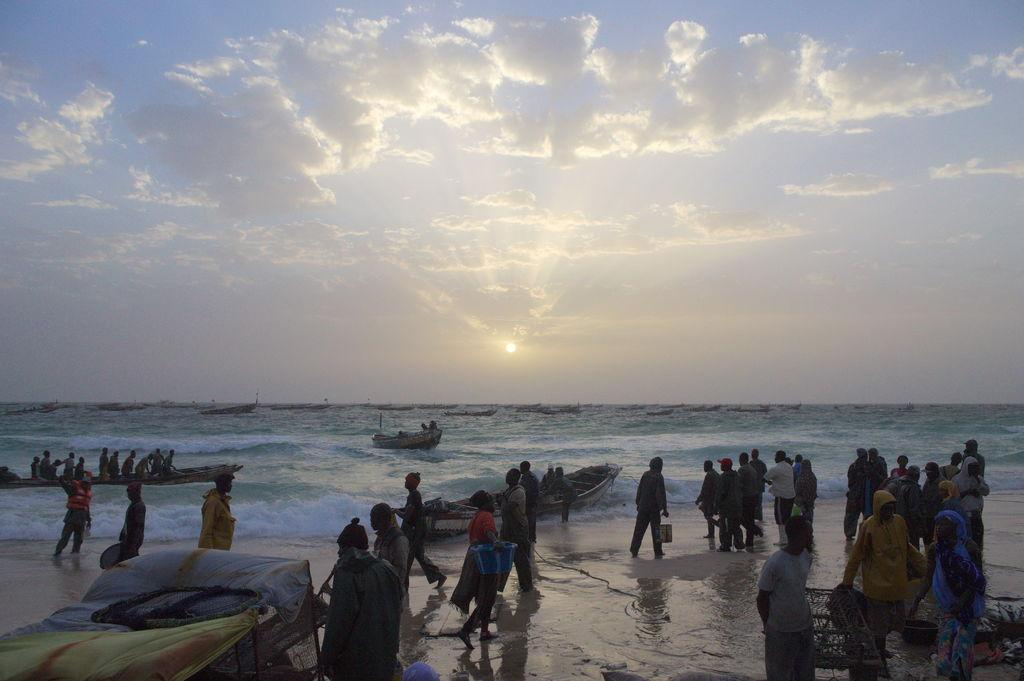What is happening in the image involving the group of people? In the image, some people are walking, while others are standing. Can you describe the setting in which the group of people is located? The group of people is located near boats on the water, with the sky visible in the background. What colors can be seen in the sky in the image? The sky in the image has blue and white colors. What type of argument is taking place between the dad and the birthday celebrant in the image? There is no dad or birthday celebrant present in the image, and therefore no argument can be observed. 